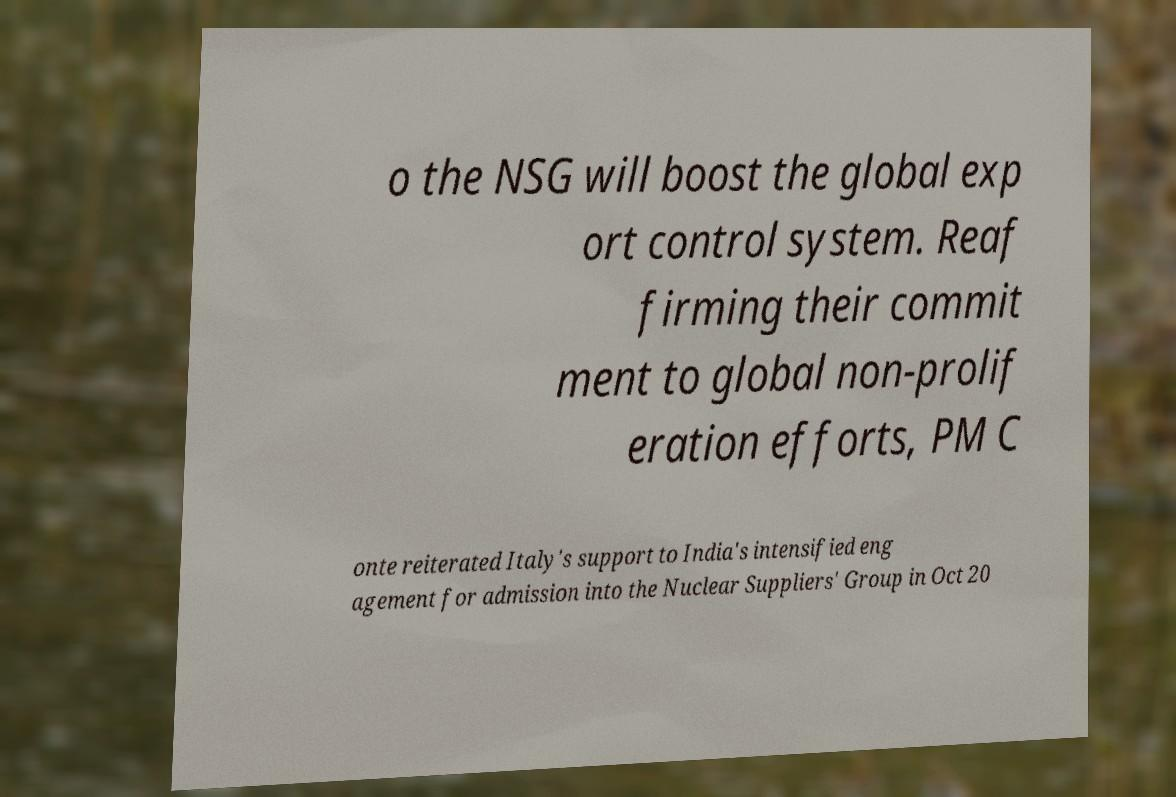Can you accurately transcribe the text from the provided image for me? o the NSG will boost the global exp ort control system. Reaf firming their commit ment to global non-prolif eration efforts, PM C onte reiterated Italy's support to India's intensified eng agement for admission into the Nuclear Suppliers' Group in Oct 20 